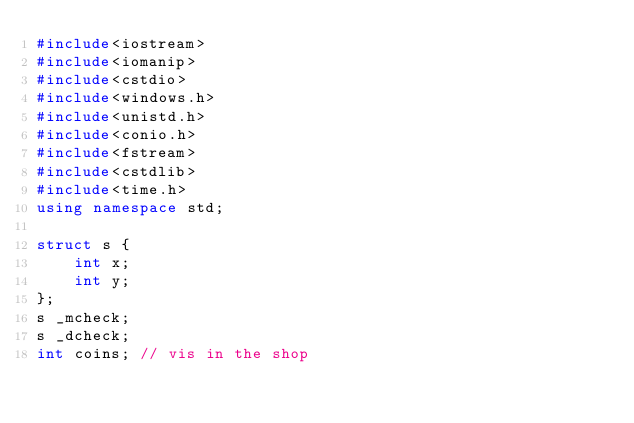Convert code to text. <code><loc_0><loc_0><loc_500><loc_500><_C++_>#include<iostream>
#include<iomanip>
#include<cstdio>
#include<windows.h>
#include<unistd.h>
#include<conio.h>
#include<fstream>
#include<cstdlib>
#include<time.h>
using namespace std;

struct s {
	int x;
	int y;
};
s _mcheck;
s _dcheck;
int coins; // vis in the shop</code> 